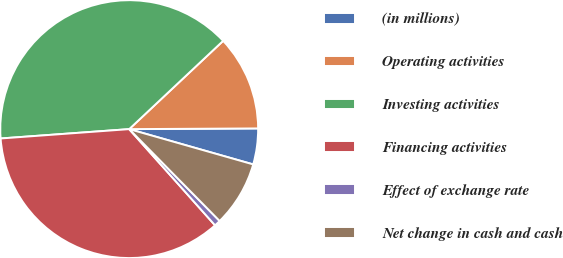<chart> <loc_0><loc_0><loc_500><loc_500><pie_chart><fcel>(in millions)<fcel>Operating activities<fcel>Investing activities<fcel>Financing activities<fcel>Effect of exchange rate<fcel>Net change in cash and cash<nl><fcel>4.5%<fcel>11.92%<fcel>39.15%<fcel>35.44%<fcel>0.78%<fcel>8.21%<nl></chart> 